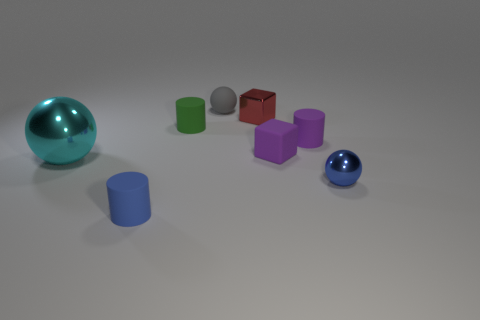Do the blue metal sphere and the gray matte sphere have the same size?
Give a very brief answer. Yes. How many cylinders are either purple rubber objects or cyan things?
Make the answer very short. 1. How many shiny balls are in front of the small blue object that is behind the blue cylinder?
Your answer should be very brief. 0. Is the shape of the red object the same as the large cyan metal object?
Your answer should be compact. No. What size is the blue object that is the same shape as the big cyan object?
Your response must be concise. Small. There is a tiny green thing in front of the tiny rubber object behind the small green matte thing; what shape is it?
Ensure brevity in your answer.  Cylinder. How big is the gray sphere?
Your response must be concise. Small. What is the shape of the small gray matte thing?
Make the answer very short. Sphere. There is a cyan shiny thing; is its shape the same as the blue object to the left of the small red object?
Make the answer very short. No. Does the shiny object that is to the left of the gray object have the same shape as the tiny gray matte thing?
Ensure brevity in your answer.  Yes. 